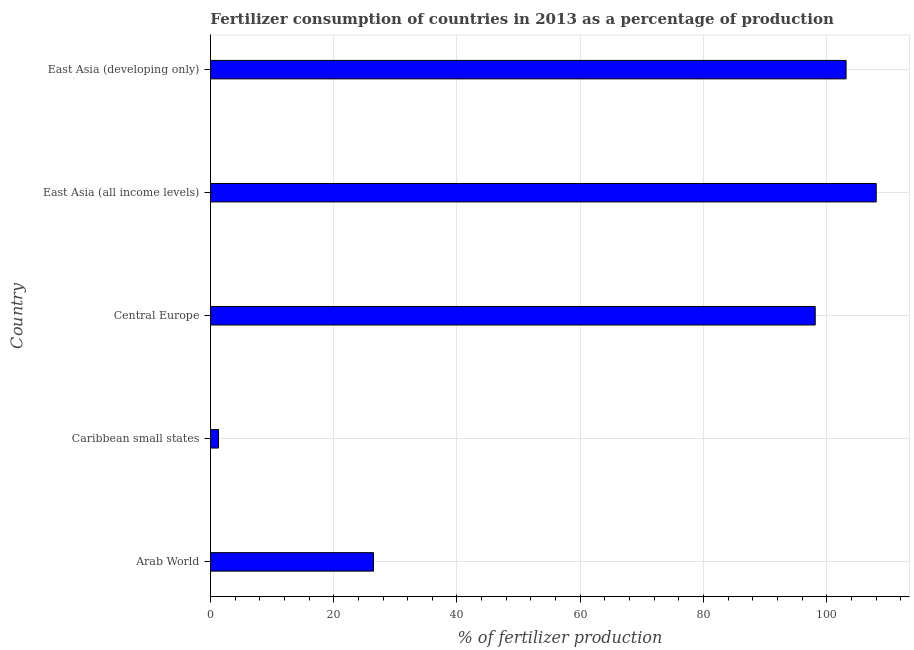What is the title of the graph?
Your answer should be compact. Fertilizer consumption of countries in 2013 as a percentage of production. What is the label or title of the X-axis?
Provide a short and direct response. % of fertilizer production. What is the amount of fertilizer consumption in Caribbean small states?
Provide a short and direct response. 1.31. Across all countries, what is the maximum amount of fertilizer consumption?
Offer a terse response. 108.03. Across all countries, what is the minimum amount of fertilizer consumption?
Offer a very short reply. 1.31. In which country was the amount of fertilizer consumption maximum?
Your response must be concise. East Asia (all income levels). In which country was the amount of fertilizer consumption minimum?
Your answer should be very brief. Caribbean small states. What is the sum of the amount of fertilizer consumption?
Provide a succinct answer. 337.06. What is the difference between the amount of fertilizer consumption in Caribbean small states and East Asia (all income levels)?
Your answer should be compact. -106.72. What is the average amount of fertilizer consumption per country?
Your answer should be compact. 67.41. What is the median amount of fertilizer consumption?
Make the answer very short. 98.13. In how many countries, is the amount of fertilizer consumption greater than 88 %?
Offer a terse response. 3. What is the ratio of the amount of fertilizer consumption in Caribbean small states to that in Central Europe?
Your response must be concise. 0.01. Is the amount of fertilizer consumption in Caribbean small states less than that in East Asia (developing only)?
Provide a succinct answer. Yes. What is the difference between the highest and the second highest amount of fertilizer consumption?
Keep it short and to the point. 4.89. Is the sum of the amount of fertilizer consumption in Arab World and East Asia (all income levels) greater than the maximum amount of fertilizer consumption across all countries?
Provide a short and direct response. Yes. What is the difference between the highest and the lowest amount of fertilizer consumption?
Ensure brevity in your answer.  106.72. Are all the bars in the graph horizontal?
Your response must be concise. Yes. How many countries are there in the graph?
Your answer should be compact. 5. What is the % of fertilizer production of Arab World?
Give a very brief answer. 26.45. What is the % of fertilizer production of Caribbean small states?
Offer a very short reply. 1.31. What is the % of fertilizer production in Central Europe?
Offer a terse response. 98.13. What is the % of fertilizer production of East Asia (all income levels)?
Offer a very short reply. 108.03. What is the % of fertilizer production in East Asia (developing only)?
Keep it short and to the point. 103.14. What is the difference between the % of fertilizer production in Arab World and Caribbean small states?
Your answer should be very brief. 25.15. What is the difference between the % of fertilizer production in Arab World and Central Europe?
Give a very brief answer. -71.68. What is the difference between the % of fertilizer production in Arab World and East Asia (all income levels)?
Provide a short and direct response. -81.57. What is the difference between the % of fertilizer production in Arab World and East Asia (developing only)?
Your response must be concise. -76.68. What is the difference between the % of fertilizer production in Caribbean small states and Central Europe?
Keep it short and to the point. -96.82. What is the difference between the % of fertilizer production in Caribbean small states and East Asia (all income levels)?
Your answer should be very brief. -106.72. What is the difference between the % of fertilizer production in Caribbean small states and East Asia (developing only)?
Your response must be concise. -101.83. What is the difference between the % of fertilizer production in Central Europe and East Asia (all income levels)?
Provide a succinct answer. -9.9. What is the difference between the % of fertilizer production in Central Europe and East Asia (developing only)?
Provide a succinct answer. -5.01. What is the difference between the % of fertilizer production in East Asia (all income levels) and East Asia (developing only)?
Offer a terse response. 4.89. What is the ratio of the % of fertilizer production in Arab World to that in Caribbean small states?
Give a very brief answer. 20.23. What is the ratio of the % of fertilizer production in Arab World to that in Central Europe?
Offer a terse response. 0.27. What is the ratio of the % of fertilizer production in Arab World to that in East Asia (all income levels)?
Keep it short and to the point. 0.24. What is the ratio of the % of fertilizer production in Arab World to that in East Asia (developing only)?
Ensure brevity in your answer.  0.26. What is the ratio of the % of fertilizer production in Caribbean small states to that in Central Europe?
Keep it short and to the point. 0.01. What is the ratio of the % of fertilizer production in Caribbean small states to that in East Asia (all income levels)?
Ensure brevity in your answer.  0.01. What is the ratio of the % of fertilizer production in Caribbean small states to that in East Asia (developing only)?
Offer a terse response. 0.01. What is the ratio of the % of fertilizer production in Central Europe to that in East Asia (all income levels)?
Your response must be concise. 0.91. What is the ratio of the % of fertilizer production in Central Europe to that in East Asia (developing only)?
Offer a terse response. 0.95. What is the ratio of the % of fertilizer production in East Asia (all income levels) to that in East Asia (developing only)?
Provide a succinct answer. 1.05. 